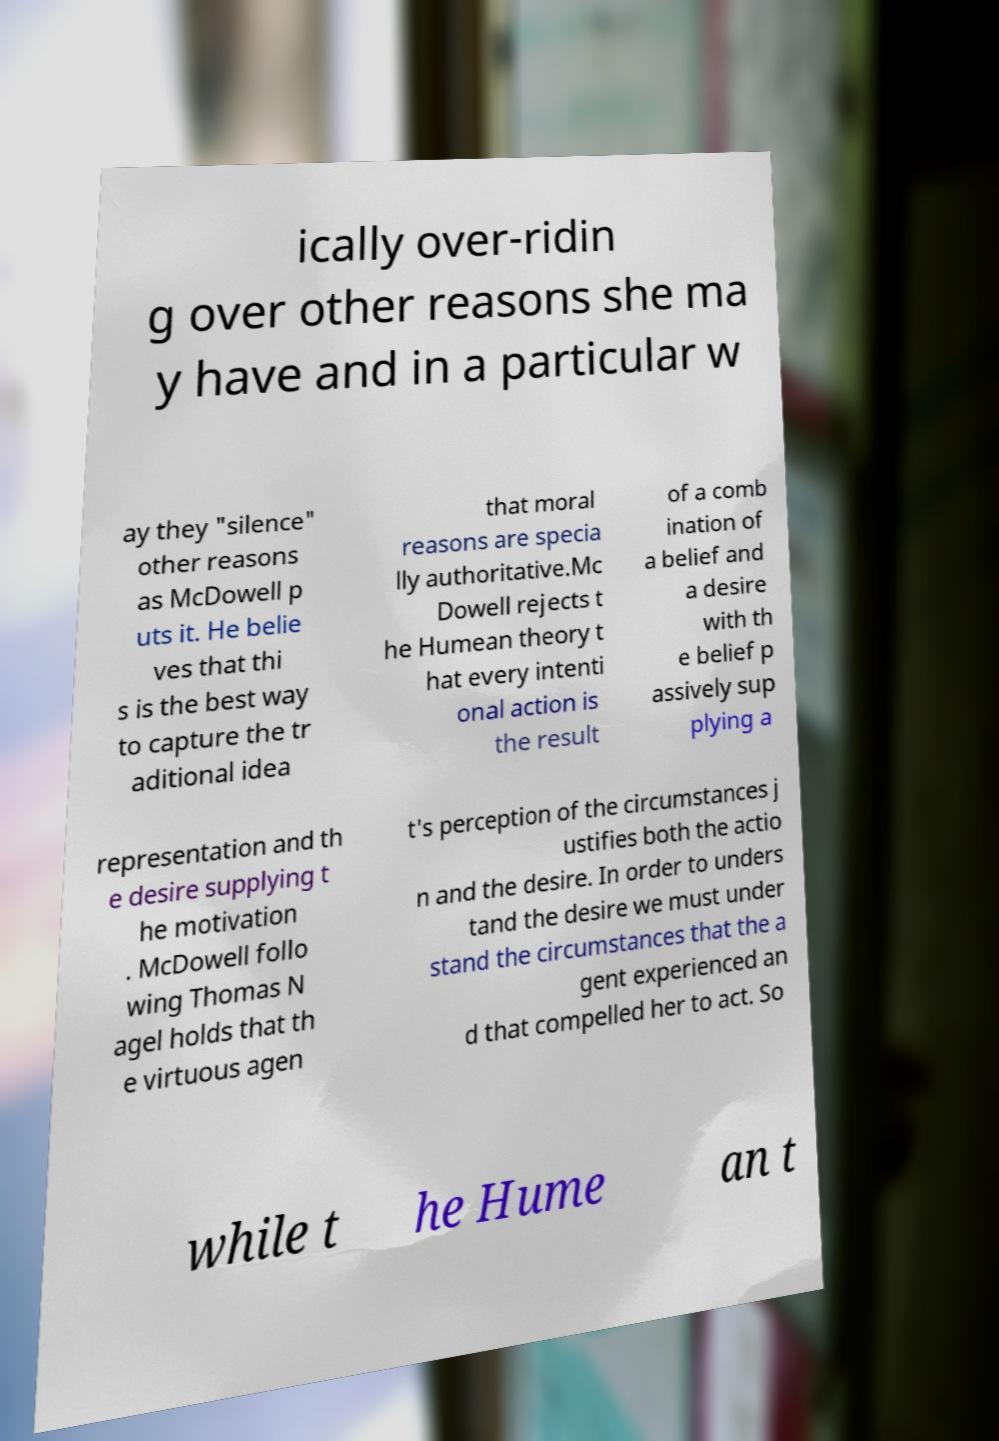Please identify and transcribe the text found in this image. ically over-ridin g over other reasons she ma y have and in a particular w ay they "silence" other reasons as McDowell p uts it. He belie ves that thi s is the best way to capture the tr aditional idea that moral reasons are specia lly authoritative.Mc Dowell rejects t he Humean theory t hat every intenti onal action is the result of a comb ination of a belief and a desire with th e belief p assively sup plying a representation and th e desire supplying t he motivation . McDowell follo wing Thomas N agel holds that th e virtuous agen t's perception of the circumstances j ustifies both the actio n and the desire. In order to unders tand the desire we must under stand the circumstances that the a gent experienced an d that compelled her to act. So while t he Hume an t 